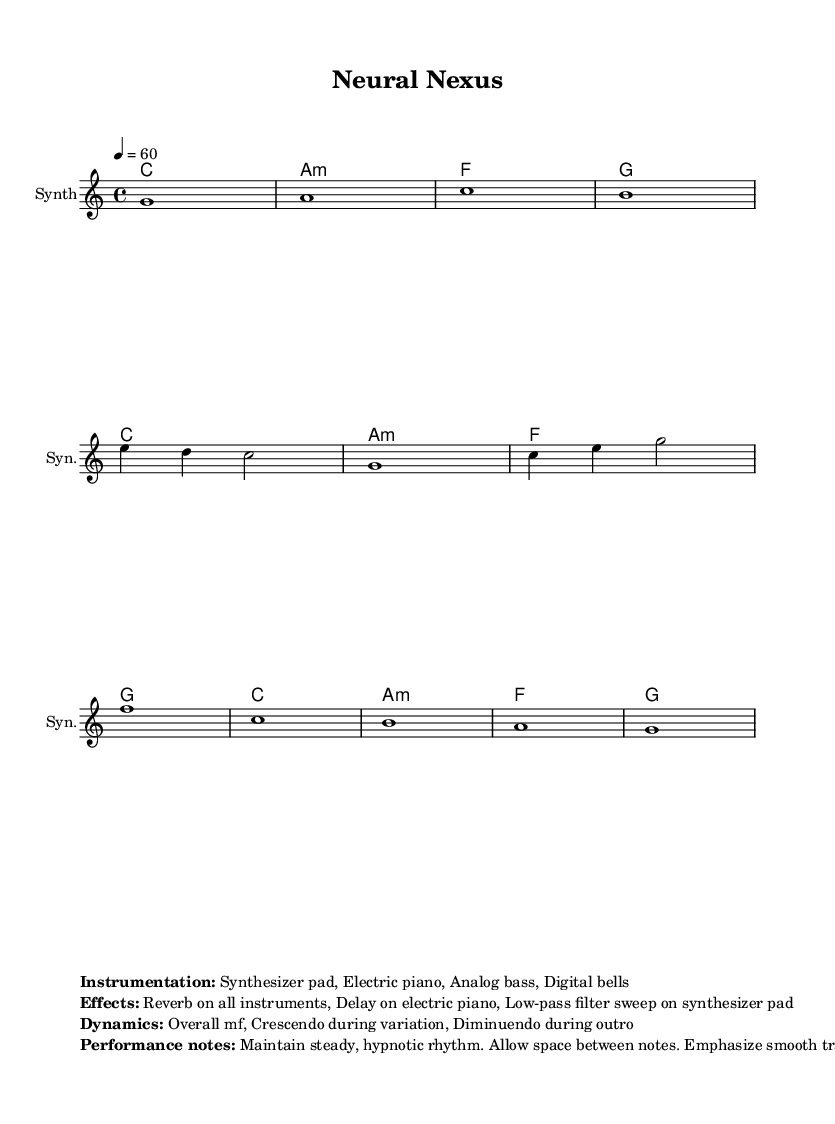What is the key signature of this music? The key signature is C major, which has no sharps or flats.
Answer: C major What is the time signature of this piece? The time signature is indicated as 4/4, meaning there are four beats in each measure.
Answer: 4/4 What is the tempo marking for this composition? The tempo marking indicates a speed of 60 beats per minute, which is relatively slow and allows for a relaxed, ambient feel.
Answer: 60 How many measures are in the main theme? The main theme consists of four measures, as counted within the provided segment of the score.
Answer: 4 What is the dynamic level for the performance? The overall dynamic level is marked as mf, which means "mezzo-forte," or moderately loud, creating an immersive environment without overwhelming intensity.
Answer: mf What types of instruments are used in this piece? The instrumentation includes a synthesizer pad, electric piano, analog bass, and digital bells, which are characteristic for creating ambient soundscapes.
Answer: Synthesizer pad, Electric piano, Analog bass, Digital bells What effect is applied to all instruments? The effect applied to all instruments is reverb, enhancing the spatial quality and creating a more atmospheric sound.
Answer: Reverb 